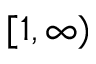Convert formula to latex. <formula><loc_0><loc_0><loc_500><loc_500>[ 1 , \infty )</formula> 